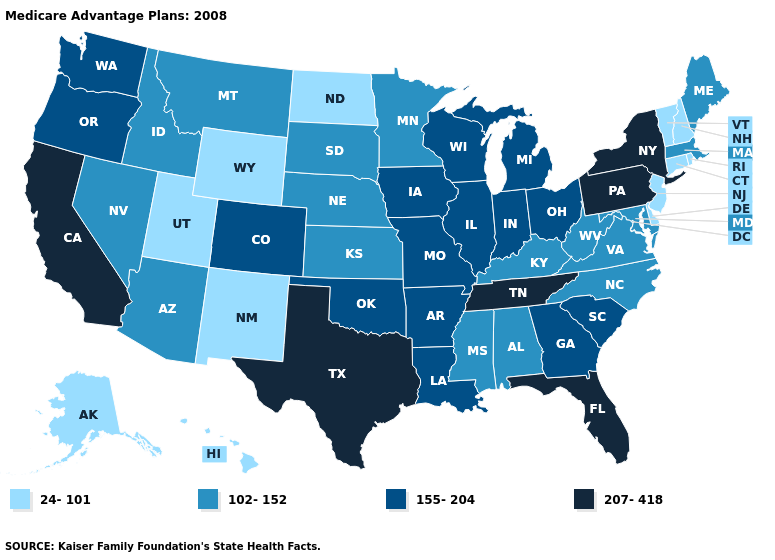Among the states that border Rhode Island , does Connecticut have the lowest value?
Short answer required. Yes. Among the states that border Maryland , which have the highest value?
Give a very brief answer. Pennsylvania. What is the value of Nebraska?
Give a very brief answer. 102-152. What is the value of North Carolina?
Give a very brief answer. 102-152. Which states have the highest value in the USA?
Short answer required. California, Florida, New York, Pennsylvania, Tennessee, Texas. Name the states that have a value in the range 155-204?
Be succinct. Arkansas, Colorado, Georgia, Iowa, Illinois, Indiana, Louisiana, Michigan, Missouri, Ohio, Oklahoma, Oregon, South Carolina, Washington, Wisconsin. Does Kentucky have the highest value in the USA?
Be succinct. No. What is the lowest value in the USA?
Quick response, please. 24-101. What is the highest value in states that border Connecticut?
Concise answer only. 207-418. Does Ohio have a higher value than Maryland?
Answer briefly. Yes. Is the legend a continuous bar?
Keep it brief. No. What is the value of Texas?
Keep it brief. 207-418. Does South Dakota have the lowest value in the MidWest?
Concise answer only. No. Name the states that have a value in the range 155-204?
Quick response, please. Arkansas, Colorado, Georgia, Iowa, Illinois, Indiana, Louisiana, Michigan, Missouri, Ohio, Oklahoma, Oregon, South Carolina, Washington, Wisconsin. Name the states that have a value in the range 102-152?
Give a very brief answer. Alabama, Arizona, Idaho, Kansas, Kentucky, Massachusetts, Maryland, Maine, Minnesota, Mississippi, Montana, North Carolina, Nebraska, Nevada, South Dakota, Virginia, West Virginia. 